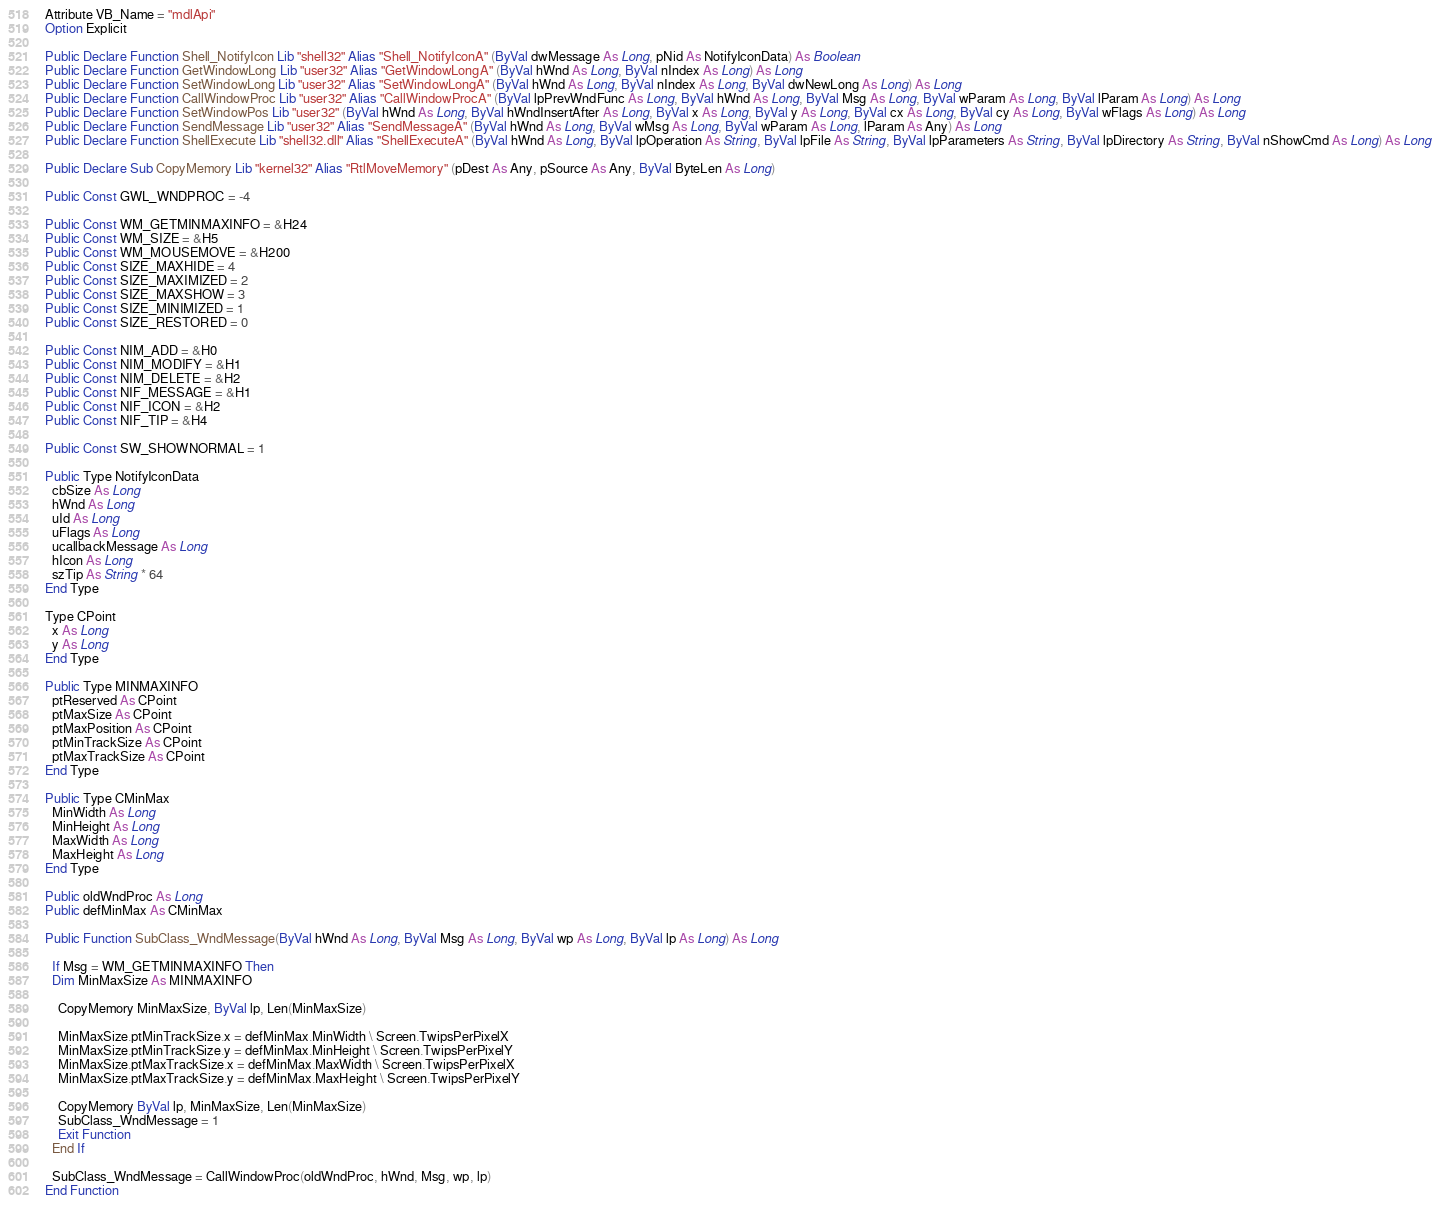<code> <loc_0><loc_0><loc_500><loc_500><_VisualBasic_>Attribute VB_Name = "mdlApi"
Option Explicit

Public Declare Function Shell_NotifyIcon Lib "shell32" Alias "Shell_NotifyIconA" (ByVal dwMessage As Long, pNid As NotifyIconData) As Boolean
Public Declare Function GetWindowLong Lib "user32" Alias "GetWindowLongA" (ByVal hWnd As Long, ByVal nIndex As Long) As Long
Public Declare Function SetWindowLong Lib "user32" Alias "SetWindowLongA" (ByVal hWnd As Long, ByVal nIndex As Long, ByVal dwNewLong As Long) As Long
Public Declare Function CallWindowProc Lib "user32" Alias "CallWindowProcA" (ByVal lpPrevWndFunc As Long, ByVal hWnd As Long, ByVal Msg As Long, ByVal wParam As Long, ByVal lParam As Long) As Long
Public Declare Function SetWindowPos Lib "user32" (ByVal hWnd As Long, ByVal hWndInsertAfter As Long, ByVal x As Long, ByVal y As Long, ByVal cx As Long, ByVal cy As Long, ByVal wFlags As Long) As Long
Public Declare Function SendMessage Lib "user32" Alias "SendMessageA" (ByVal hWnd As Long, ByVal wMsg As Long, ByVal wParam As Long, lParam As Any) As Long
Public Declare Function ShellExecute Lib "shell32.dll" Alias "ShellExecuteA" (ByVal hWnd As Long, ByVal lpOperation As String, ByVal lpFile As String, ByVal lpParameters As String, ByVal lpDirectory As String, ByVal nShowCmd As Long) As Long

Public Declare Sub CopyMemory Lib "kernel32" Alias "RtlMoveMemory" (pDest As Any, pSource As Any, ByVal ByteLen As Long)

Public Const GWL_WNDPROC = -4

Public Const WM_GETMINMAXINFO = &H24
Public Const WM_SIZE = &H5
Public Const WM_MOUSEMOVE = &H200
Public Const SIZE_MAXHIDE = 4
Public Const SIZE_MAXIMIZED = 2
Public Const SIZE_MAXSHOW = 3
Public Const SIZE_MINIMIZED = 1
Public Const SIZE_RESTORED = 0

Public Const NIM_ADD = &H0
Public Const NIM_MODIFY = &H1
Public Const NIM_DELETE = &H2
Public Const NIF_MESSAGE = &H1
Public Const NIF_ICON = &H2
Public Const NIF_TIP = &H4

Public Const SW_SHOWNORMAL = 1

Public Type NotifyIconData
  cbSize As Long
  hWnd As Long
  uId As Long
  uFlags As Long
  ucallbackMessage As Long
  hIcon As Long
  szTip As String * 64
End Type

Type CPoint
  x As Long
  y As Long
End Type

Public Type MINMAXINFO
  ptReserved As CPoint
  ptMaxSize As CPoint
  ptMaxPosition As CPoint
  ptMinTrackSize As CPoint
  ptMaxTrackSize As CPoint
End Type

Public Type CMinMax
  MinWidth As Long
  MinHeight As Long
  MaxWidth As Long
  MaxHeight As Long
End Type

Public oldWndProc As Long
Public defMinMax As CMinMax

Public Function SubClass_WndMessage(ByVal hWnd As Long, ByVal Msg As Long, ByVal wp As Long, ByVal lp As Long) As Long

  If Msg = WM_GETMINMAXINFO Then
  Dim MinMaxSize As MINMAXINFO

    CopyMemory MinMaxSize, ByVal lp, Len(MinMaxSize)
  
    MinMaxSize.ptMinTrackSize.x = defMinMax.MinWidth \ Screen.TwipsPerPixelX
    MinMaxSize.ptMinTrackSize.y = defMinMax.MinHeight \ Screen.TwipsPerPixelY
    MinMaxSize.ptMaxTrackSize.x = defMinMax.MaxWidth \ Screen.TwipsPerPixelX
    MinMaxSize.ptMaxTrackSize.y = defMinMax.MaxHeight \ Screen.TwipsPerPixelY
        
    CopyMemory ByVal lp, MinMaxSize, Len(MinMaxSize)
    SubClass_WndMessage = 1
    Exit Function
  End If
  
  SubClass_WndMessage = CallWindowProc(oldWndProc, hWnd, Msg, wp, lp)
End Function



</code> 